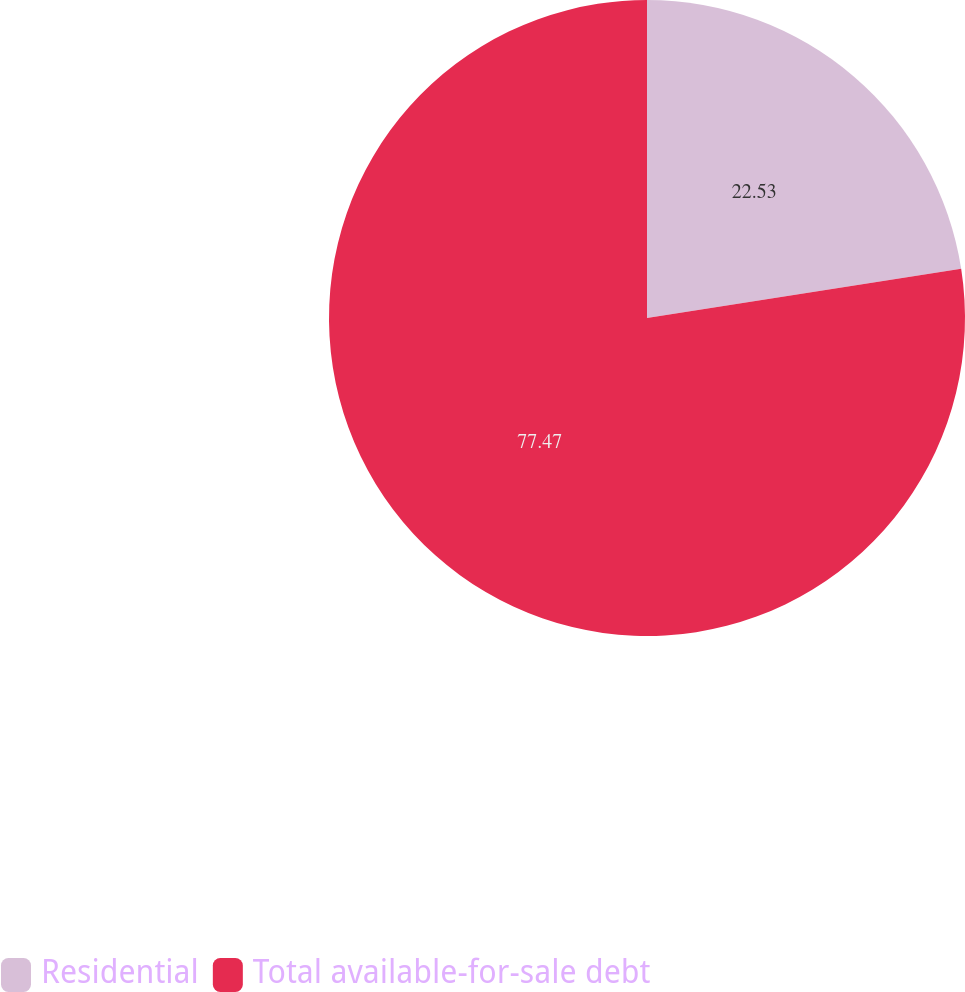<chart> <loc_0><loc_0><loc_500><loc_500><pie_chart><fcel>Residential<fcel>Total available-for-sale debt<nl><fcel>22.53%<fcel>77.47%<nl></chart> 